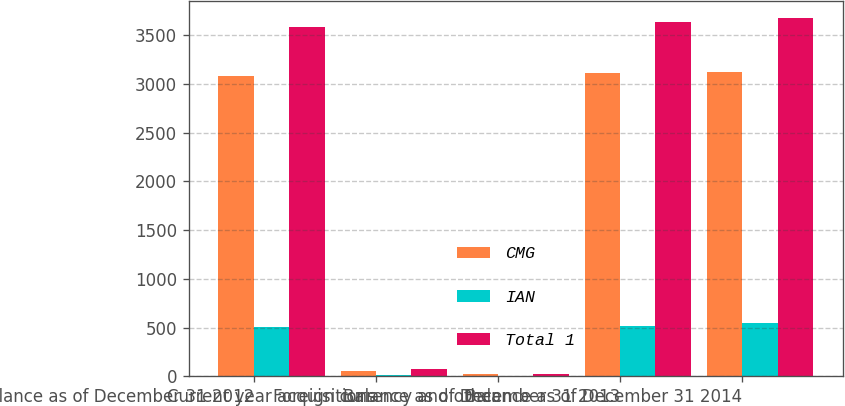Convert chart. <chart><loc_0><loc_0><loc_500><loc_500><stacked_bar_chart><ecel><fcel>Balance as of December 31 2012<fcel>Current year acquisitions<fcel>Foreign currency and other<fcel>Balance as of December 31 2013<fcel>Balance as of December 31 2014<nl><fcel>CMG<fcel>3074.6<fcel>58.8<fcel>24.1<fcel>3109.3<fcel>3120.8<nl><fcel>IAN<fcel>506<fcel>16.5<fcel>2.8<fcel>519.7<fcel>548.4<nl><fcel>Total 1<fcel>3580.6<fcel>75.3<fcel>26.9<fcel>3629<fcel>3669.2<nl></chart> 